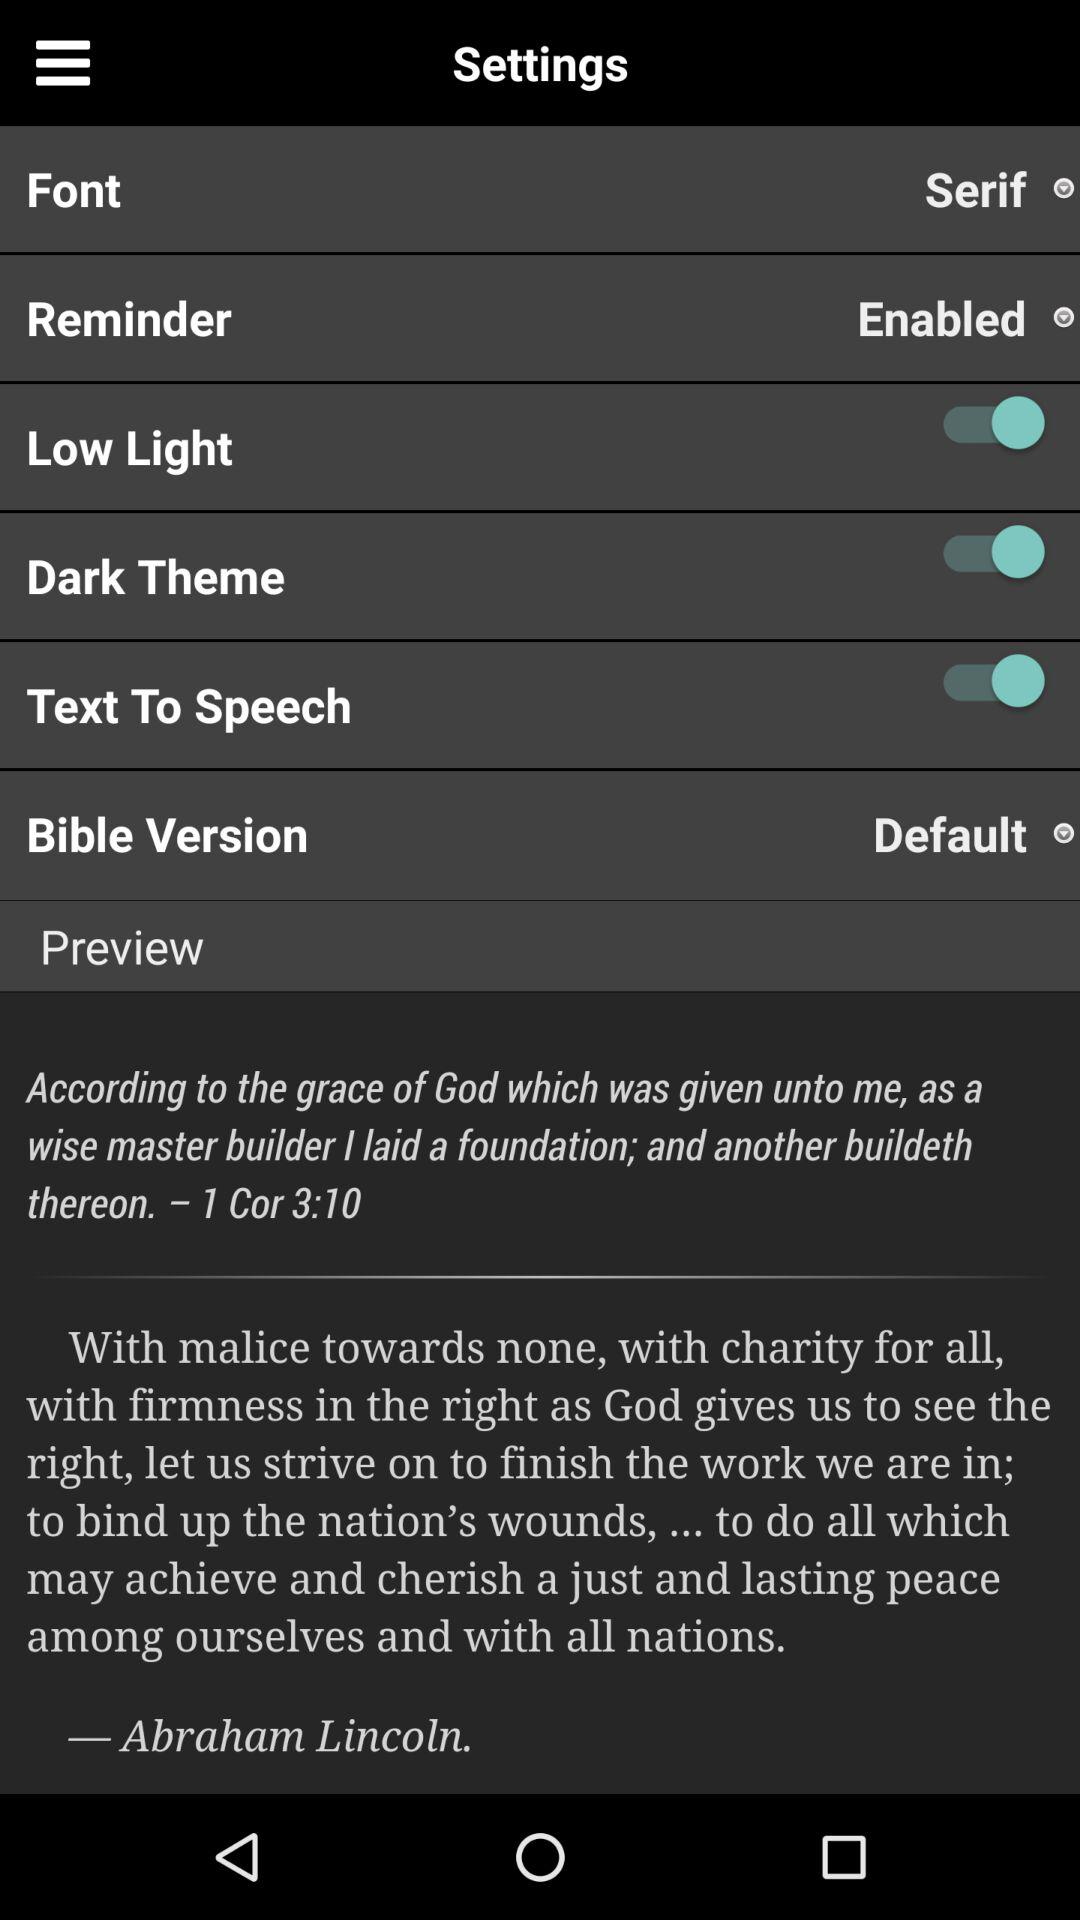What is the status of the low light? The status is on. 